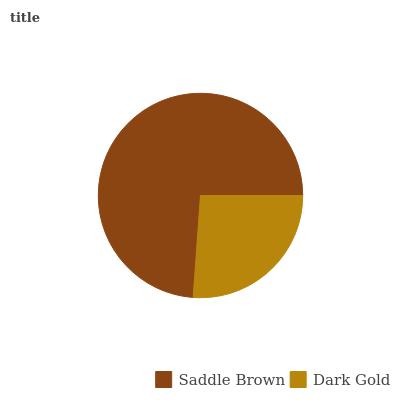Is Dark Gold the minimum?
Answer yes or no. Yes. Is Saddle Brown the maximum?
Answer yes or no. Yes. Is Dark Gold the maximum?
Answer yes or no. No. Is Saddle Brown greater than Dark Gold?
Answer yes or no. Yes. Is Dark Gold less than Saddle Brown?
Answer yes or no. Yes. Is Dark Gold greater than Saddle Brown?
Answer yes or no. No. Is Saddle Brown less than Dark Gold?
Answer yes or no. No. Is Saddle Brown the high median?
Answer yes or no. Yes. Is Dark Gold the low median?
Answer yes or no. Yes. Is Dark Gold the high median?
Answer yes or no. No. Is Saddle Brown the low median?
Answer yes or no. No. 